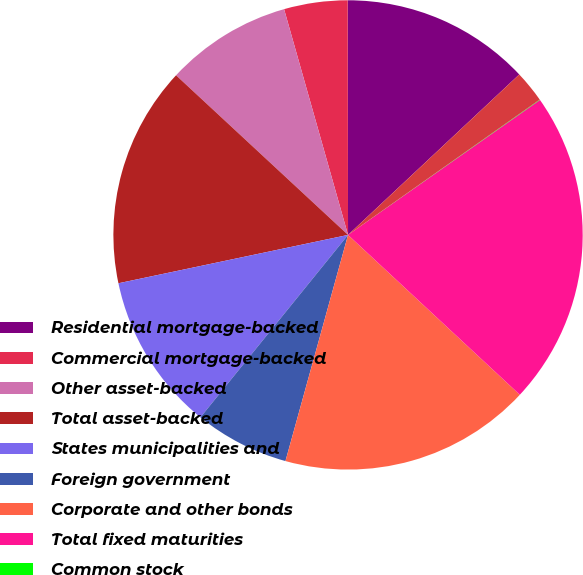Convert chart. <chart><loc_0><loc_0><loc_500><loc_500><pie_chart><fcel>Residential mortgage-backed<fcel>Commercial mortgage-backed<fcel>Other asset-backed<fcel>Total asset-backed<fcel>States municipalities and<fcel>Foreign government<fcel>Corporate and other bonds<fcel>Total fixed maturities<fcel>Common stock<fcel>Total equity securities<nl><fcel>13.04%<fcel>4.37%<fcel>8.7%<fcel>15.21%<fcel>10.87%<fcel>6.53%<fcel>17.37%<fcel>21.68%<fcel>0.03%<fcel>2.2%<nl></chart> 